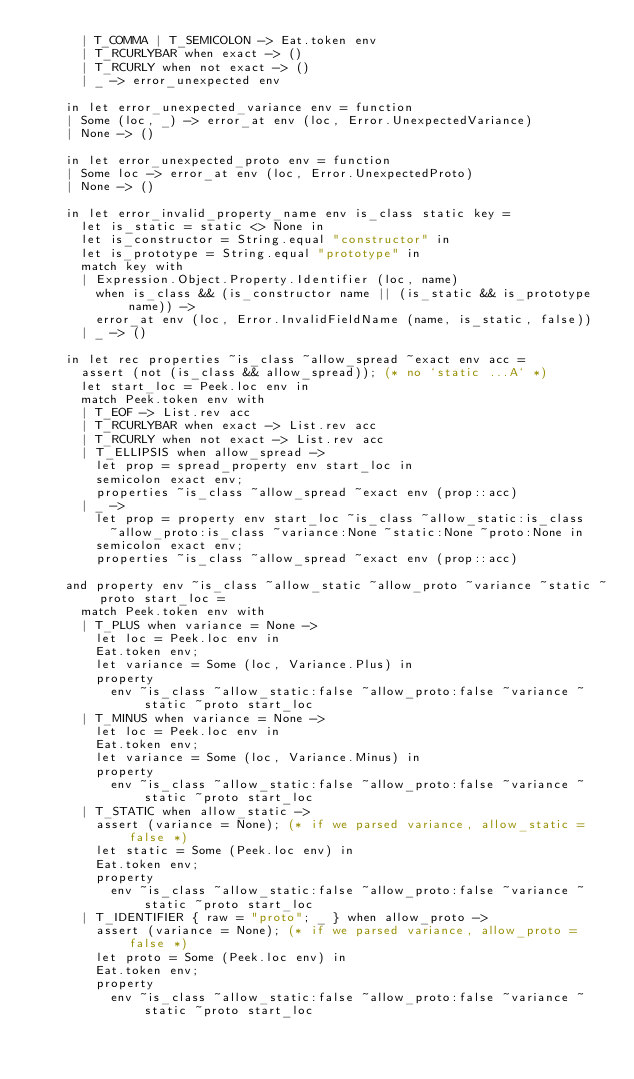Convert code to text. <code><loc_0><loc_0><loc_500><loc_500><_OCaml_>      | T_COMMA | T_SEMICOLON -> Eat.token env
      | T_RCURLYBAR when exact -> ()
      | T_RCURLY when not exact -> ()
      | _ -> error_unexpected env

    in let error_unexpected_variance env = function
    | Some (loc, _) -> error_at env (loc, Error.UnexpectedVariance)
    | None -> ()

    in let error_unexpected_proto env = function
    | Some loc -> error_at env (loc, Error.UnexpectedProto)
    | None -> ()

    in let error_invalid_property_name env is_class static key =
      let is_static = static <> None in
      let is_constructor = String.equal "constructor" in
      let is_prototype = String.equal "prototype" in
      match key with
      | Expression.Object.Property.Identifier (loc, name)
        when is_class && (is_constructor name || (is_static && is_prototype name)) ->
        error_at env (loc, Error.InvalidFieldName (name, is_static, false))
      | _ -> ()

    in let rec properties ~is_class ~allow_spread ~exact env acc =
      assert (not (is_class && allow_spread)); (* no `static ...A` *)
      let start_loc = Peek.loc env in
      match Peek.token env with
      | T_EOF -> List.rev acc
      | T_RCURLYBAR when exact -> List.rev acc
      | T_RCURLY when not exact -> List.rev acc
      | T_ELLIPSIS when allow_spread ->
        let prop = spread_property env start_loc in
        semicolon exact env;
        properties ~is_class ~allow_spread ~exact env (prop::acc)
      | _ ->
        let prop = property env start_loc ~is_class ~allow_static:is_class
          ~allow_proto:is_class ~variance:None ~static:None ~proto:None in
        semicolon exact env;
        properties ~is_class ~allow_spread ~exact env (prop::acc)

    and property env ~is_class ~allow_static ~allow_proto ~variance ~static ~proto start_loc =
      match Peek.token env with
      | T_PLUS when variance = None ->
        let loc = Peek.loc env in
        Eat.token env;
        let variance = Some (loc, Variance.Plus) in
        property
          env ~is_class ~allow_static:false ~allow_proto:false ~variance ~static ~proto start_loc
      | T_MINUS when variance = None ->
        let loc = Peek.loc env in
        Eat.token env;
        let variance = Some (loc, Variance.Minus) in
        property
          env ~is_class ~allow_static:false ~allow_proto:false ~variance ~static ~proto start_loc
      | T_STATIC when allow_static ->
        assert (variance = None); (* if we parsed variance, allow_static = false *)
        let static = Some (Peek.loc env) in
        Eat.token env;
        property
          env ~is_class ~allow_static:false ~allow_proto:false ~variance ~static ~proto start_loc
      | T_IDENTIFIER { raw = "proto"; _ } when allow_proto ->
        assert (variance = None); (* if we parsed variance, allow_proto = false *)
        let proto = Some (Peek.loc env) in
        Eat.token env;
        property
          env ~is_class ~allow_static:false ~allow_proto:false ~variance ~static ~proto start_loc</code> 